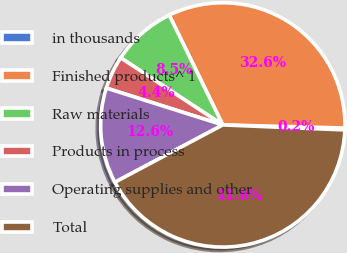Convert chart to OTSL. <chart><loc_0><loc_0><loc_500><loc_500><pie_chart><fcel>in thousands<fcel>Finished products^ 1<fcel>Raw materials<fcel>Products in process<fcel>Operating supplies and other<fcel>Total<nl><fcel>0.25%<fcel>32.63%<fcel>8.52%<fcel>4.38%<fcel>12.65%<fcel>41.58%<nl></chart> 